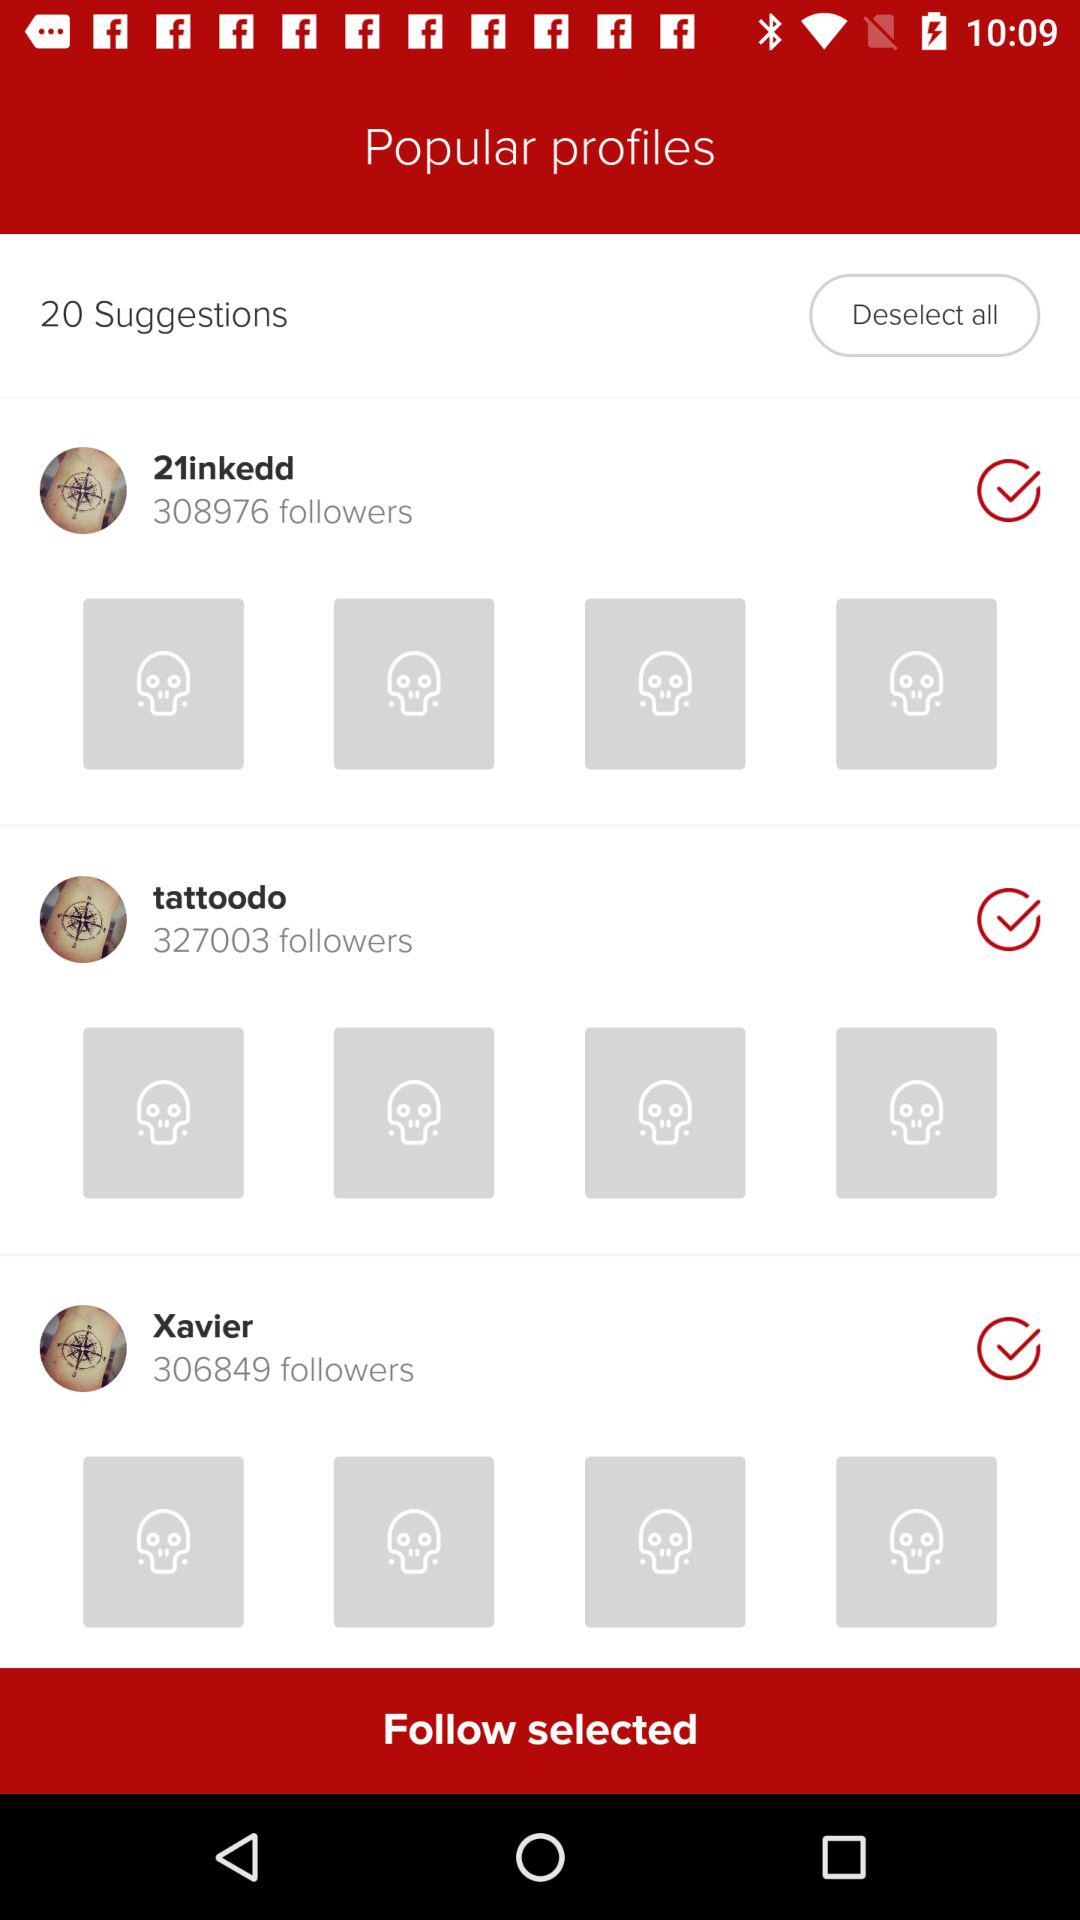How many suggestions are there? There are 20 suggestions. 